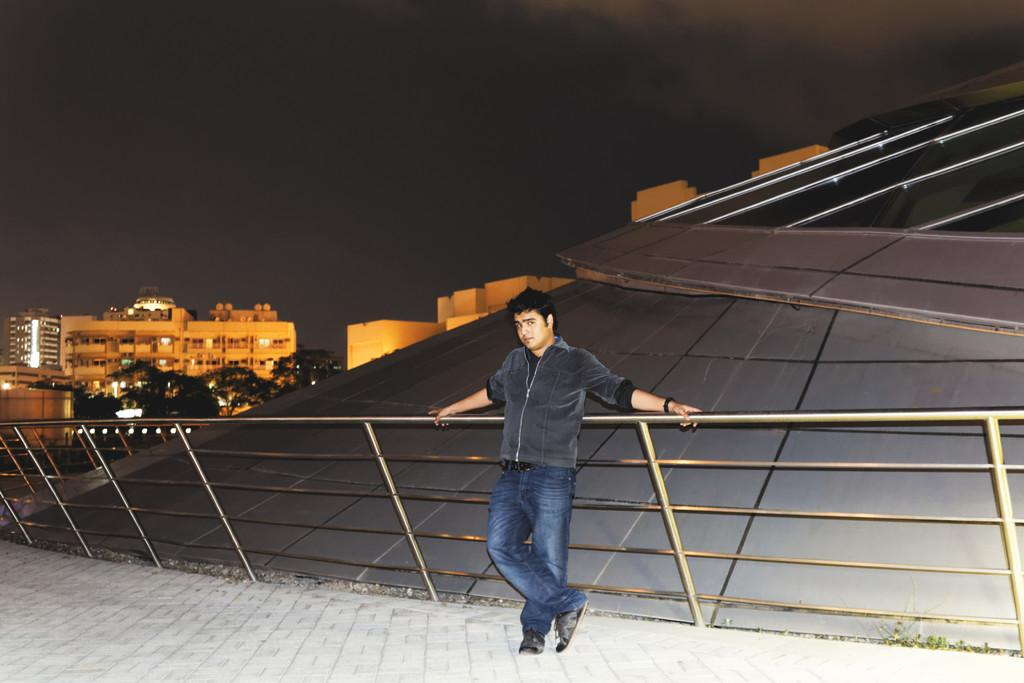What is the main subject of the image? There is a man standing in the image. What is the man wearing? The man is wearing a coat and trousers. What can be seen on the left side of the image? There are trees and buildings on the left side of the image. What is visible at the top of the image? The sky is visible at the top of the image. What type of pen is the man holding in the image? There is no pen visible in the image; the man is not holding anything. How many legs does the camera have in the image? There is no camera present in the image, so it is not possible to determine the number of legs it might have. 